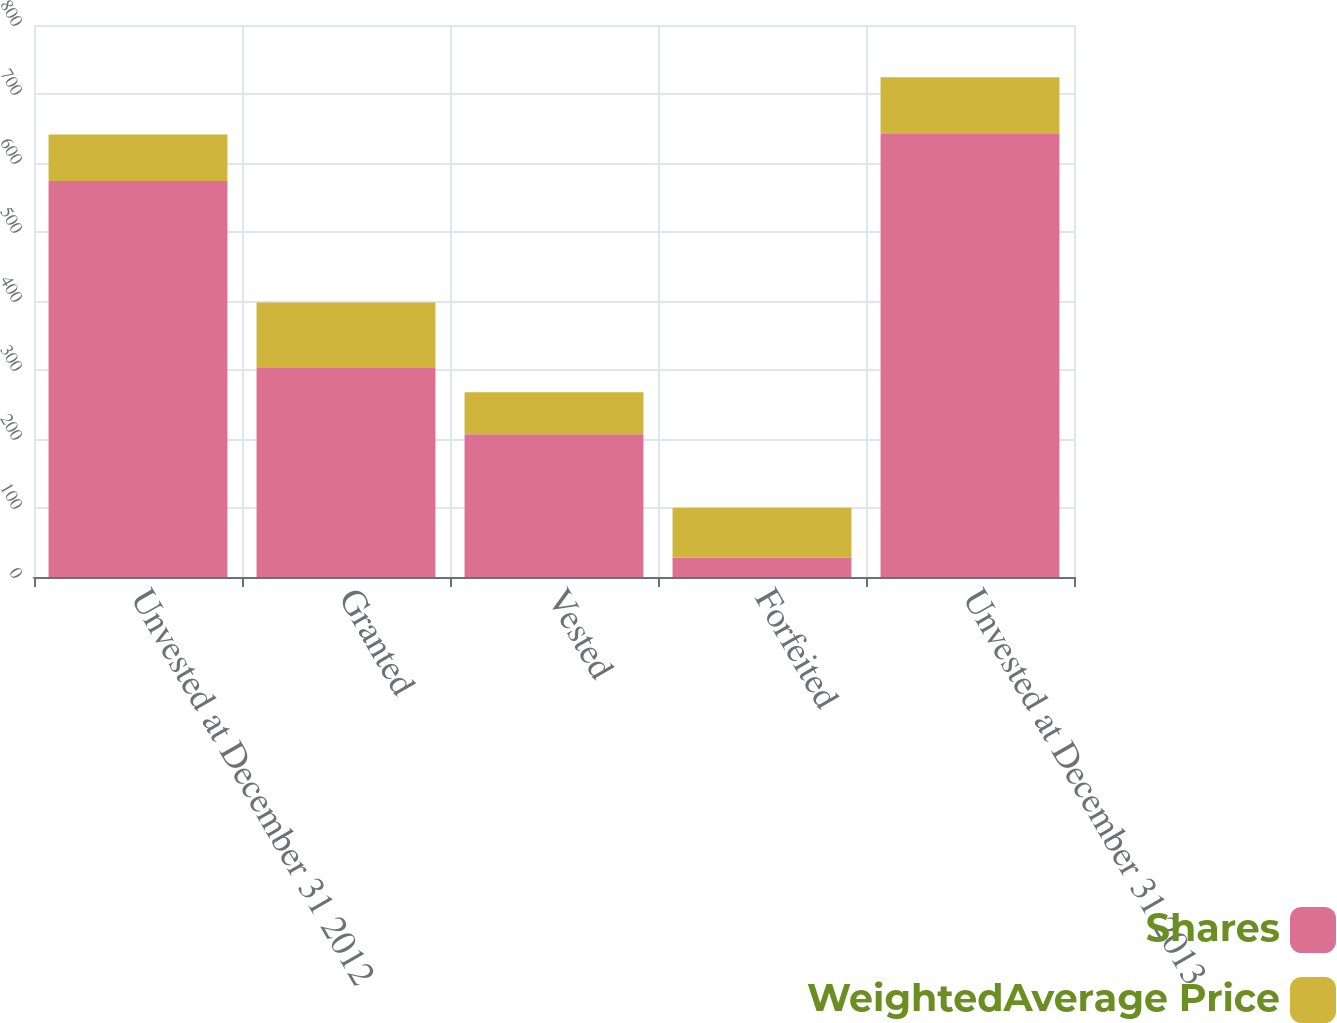Convert chart. <chart><loc_0><loc_0><loc_500><loc_500><stacked_bar_chart><ecel><fcel>Unvested at December 31 2012<fcel>Granted<fcel>Vested<fcel>Forfeited<fcel>Unvested at December 31 2013<nl><fcel>Shares<fcel>574<fcel>303<fcel>207<fcel>28<fcel>642<nl><fcel>WeightedAverage Price<fcel>67.28<fcel>94.74<fcel>60.65<fcel>72.27<fcel>82.16<nl></chart> 